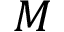Convert formula to latex. <formula><loc_0><loc_0><loc_500><loc_500>M</formula> 